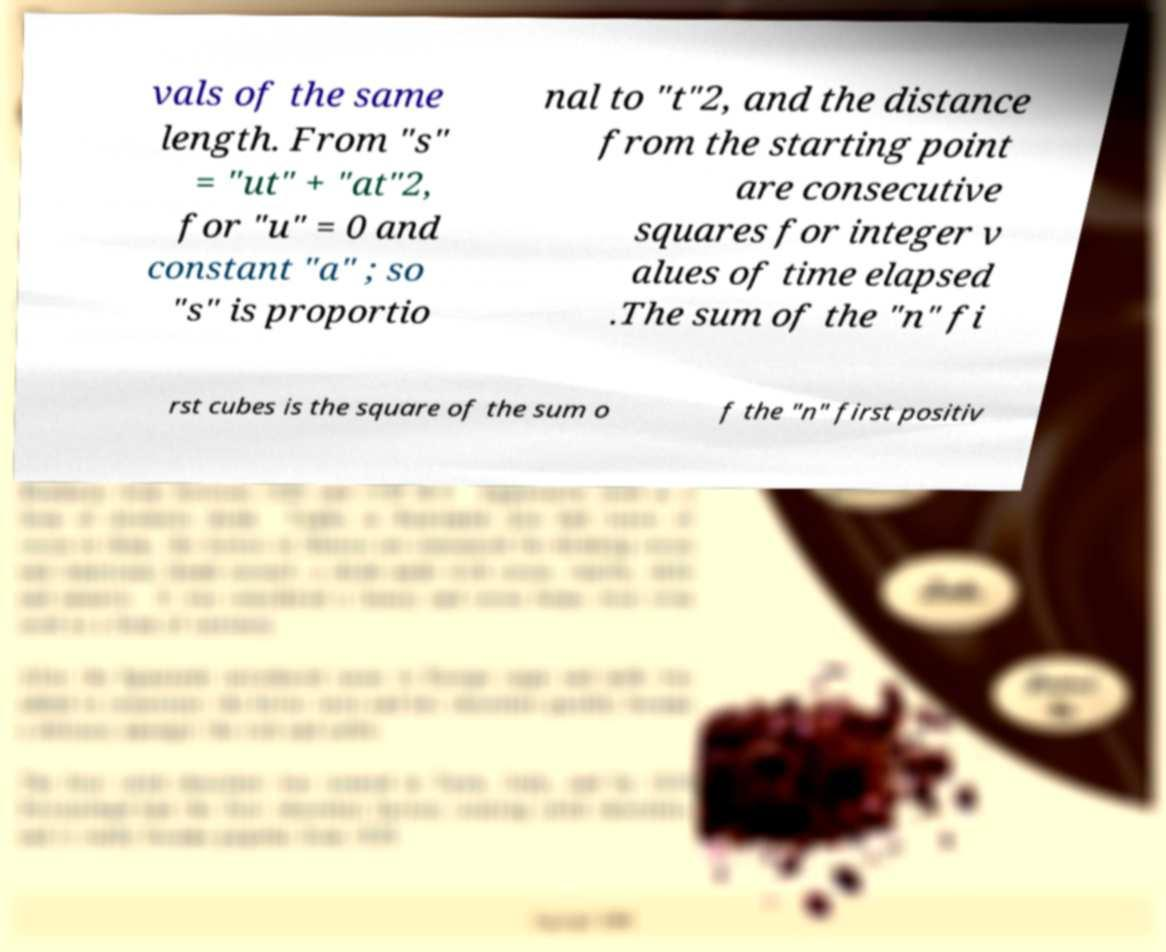Could you assist in decoding the text presented in this image and type it out clearly? vals of the same length. From "s" = "ut" + "at"2, for "u" = 0 and constant "a" ; so "s" is proportio nal to "t"2, and the distance from the starting point are consecutive squares for integer v alues of time elapsed .The sum of the "n" fi rst cubes is the square of the sum o f the "n" first positiv 